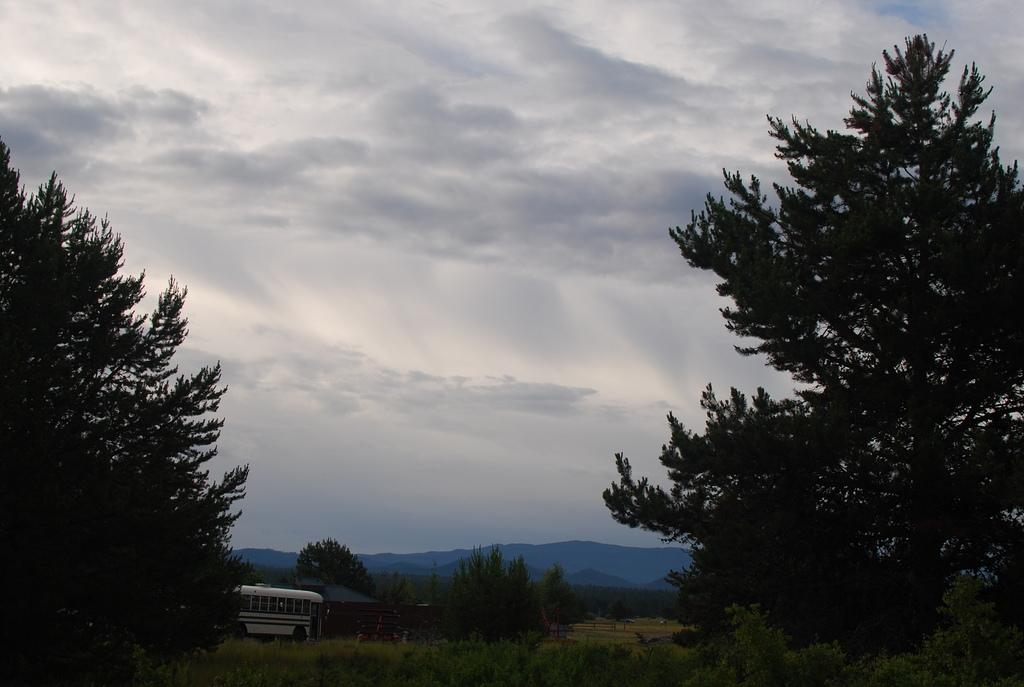What type of vegetation can be seen on the left side of the image? There are trees on the left side of the image. What type of vegetation can be seen on the right side of the image? There are trees on the right side of the image. What mode of transportation can be seen in the background of the image? There is a bus on a road in the background of the image. What other elements can be seen in the background of the image? There are trees and mountains in the background of the image. What part of the natural environment is visible in the background of the image? The sky is visible in the background of the image. Can you see a letter hanging from the trees on the left side of the image? There is no letter hanging from the trees in the image; only trees are present. Is there a scarecrow standing among the trees on the right side of the image? There is no scarecrow present among the trees on the right side of the image. 